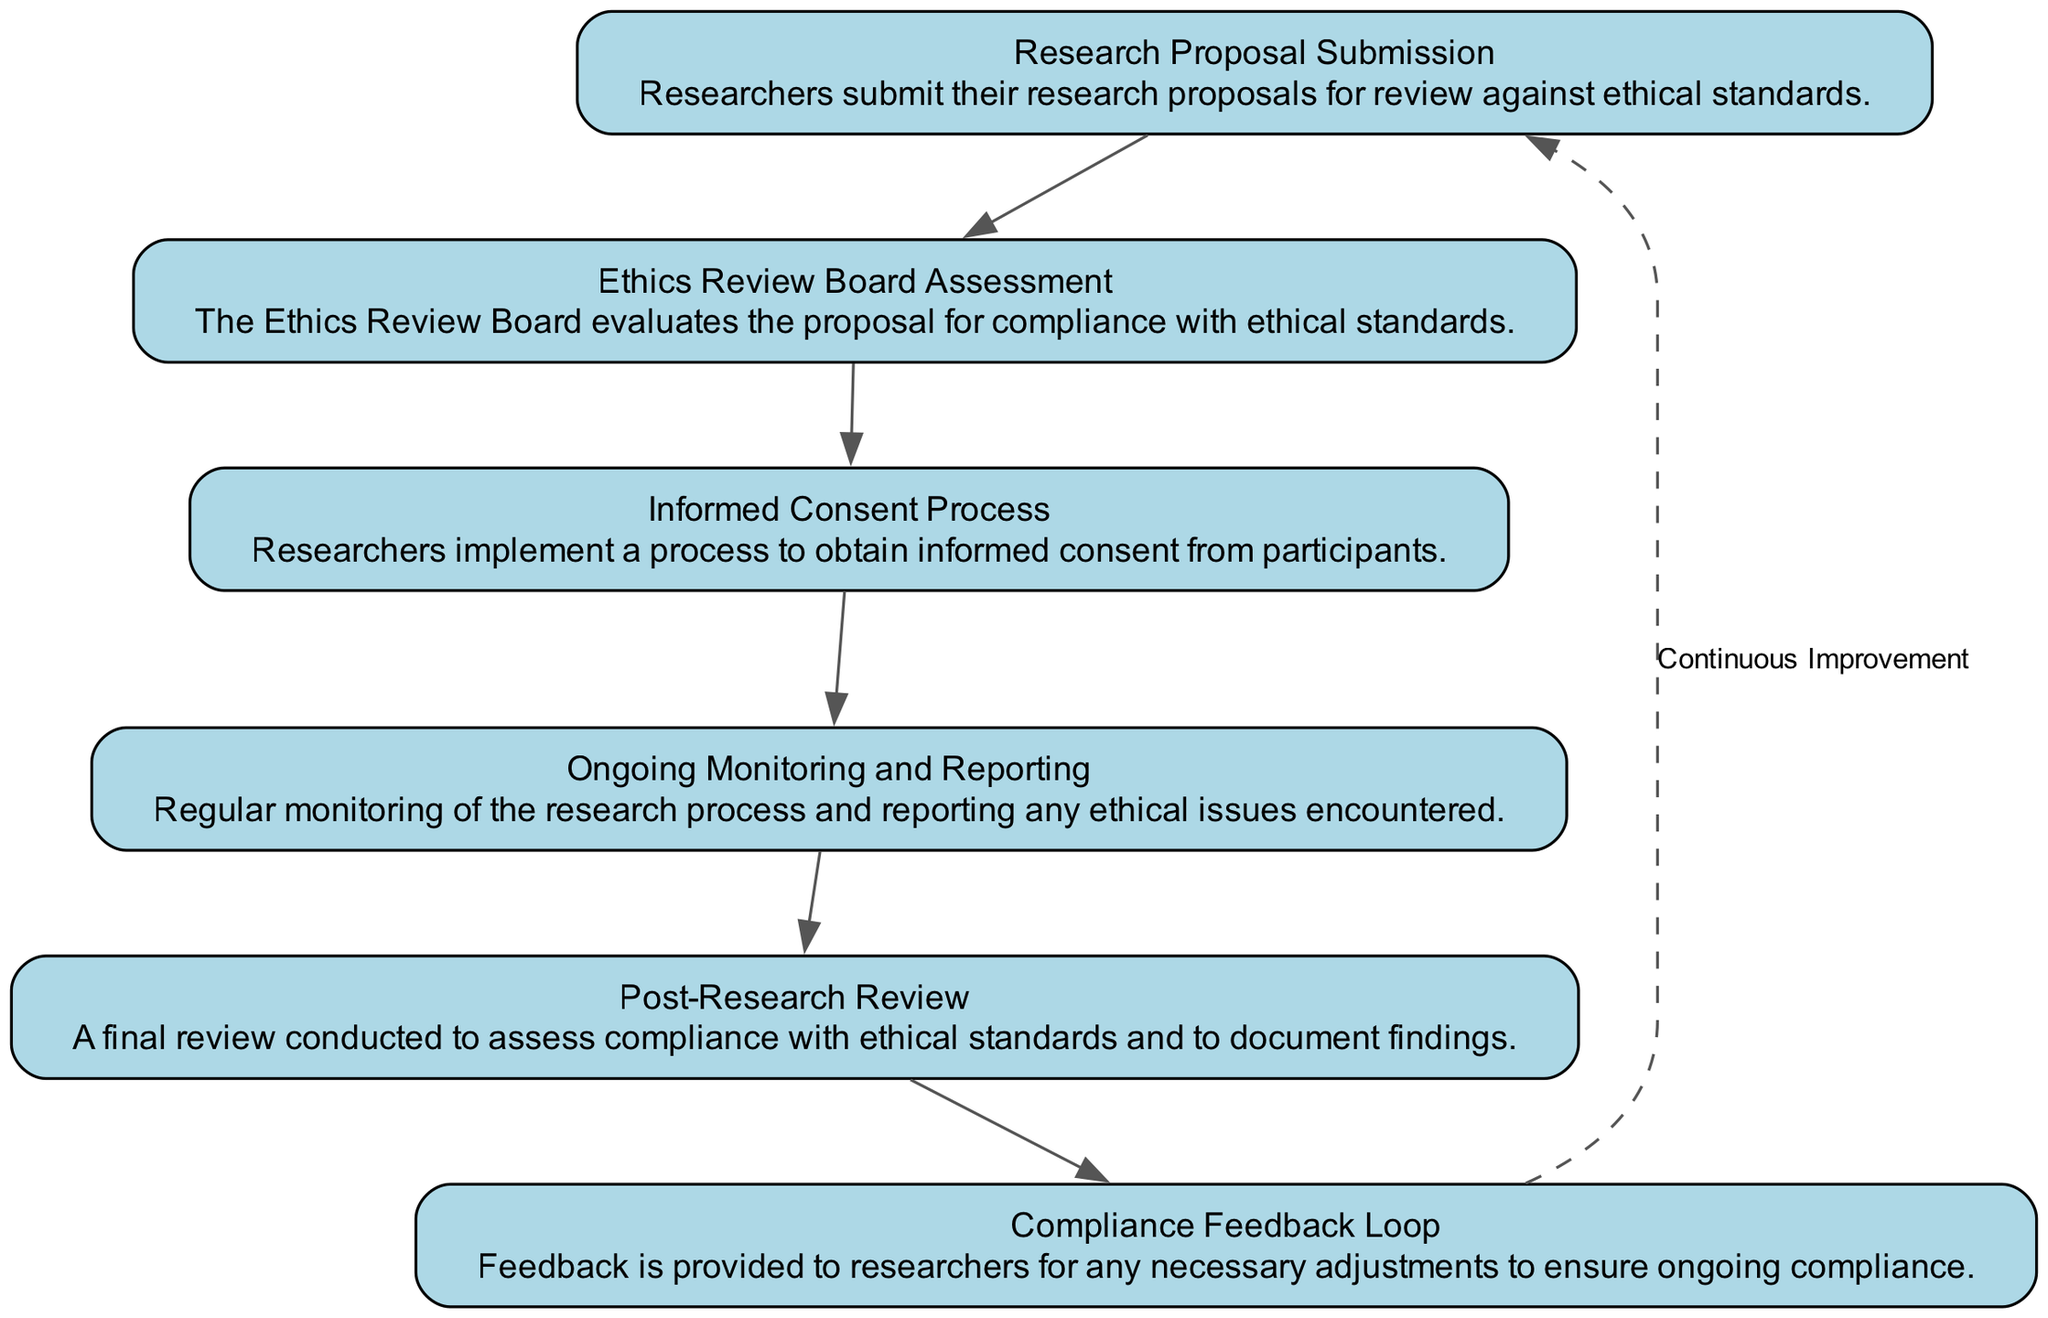What is the first step in the workflow? The first step in the workflow is indicated by the top node, which is "Research Proposal Submission". This node is the starting point for the subsequent flow of the diagram.
Answer: Research Proposal Submission How many main steps are in the workflow? Counting all the distinct nodes present in the diagram, there are a total of six main steps outlined from submission to post-research review.
Answer: 6 Which step comes after the "Informed Consent Process"? By following the directional edges from the "Informed Consent Process" node, the next step is "Ongoing Monitoring and Reporting". This indicates the sequence of actions to be taken in the workflow.
Answer: Ongoing Monitoring and Reporting What is the purpose of the "Post-Research Review"? The "Post-Research Review" node is described as a "final review conducted to assess compliance with ethical standards and to document findings", indicating its role in evaluating the preceding workflow's adherence to ethical guidelines.
Answer: To assess compliance with ethical standards How does the workflow ensure continuous improvement? Continuous improvement is depicted with a dashed edge returning from the "Post-Research Review" back to "Research Proposal Submission", labeled as "Continuous Improvement", signifying that the review process feeds back into the proposal phase for further refinement and ethical adherence.
Answer: By returning to research proposal submission What is the role of the "Ethics Review Board Assessment"? The "Ethics Review Board Assessment" node plays a critical role in evaluating the submitted proposals for compliance with established ethical standards, acting as a gatekeeping step within the workflow.
Answer: Evaluate proposals for compliance What type of feedback is provided in the "Compliance Feedback Loop"? The "Compliance Feedback Loop" provides feedback for any necessary adjustments that researchers must make in order to maintain or improve compliance with ethical standards, as indicated in its description.
Answer: Necessary adjustments for compliance What is the last step in the workflow? The last step in the workflow is identified by the bottom node, which is "Post-Research Review". This signifies that the process concludes with a thorough evaluation after the research is complete.
Answer: Post-Research Review 